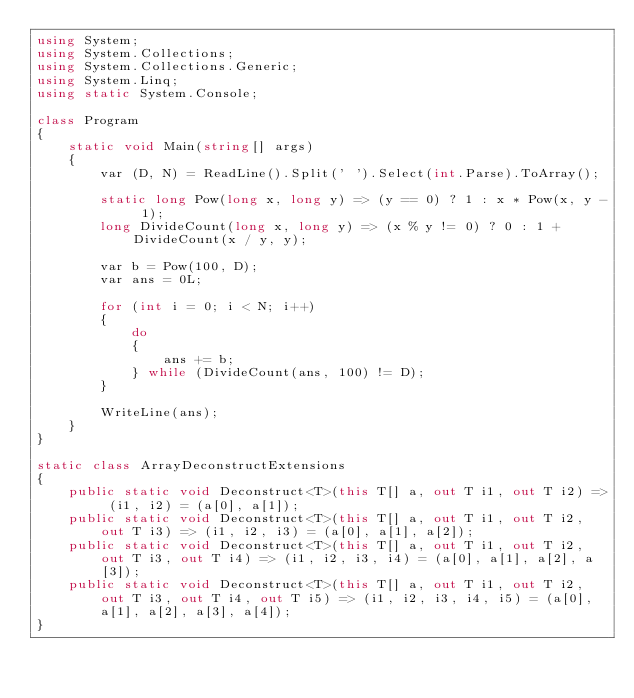Convert code to text. <code><loc_0><loc_0><loc_500><loc_500><_C#_>using System;
using System.Collections;
using System.Collections.Generic;
using System.Linq;
using static System.Console;

class Program
{
    static void Main(string[] args)
    {
        var (D, N) = ReadLine().Split(' ').Select(int.Parse).ToArray();

        static long Pow(long x, long y) => (y == 0) ? 1 : x * Pow(x, y - 1);
        long DivideCount(long x, long y) => (x % y != 0) ? 0 : 1 + DivideCount(x / y, y);

        var b = Pow(100, D);
        var ans = 0L;

        for (int i = 0; i < N; i++)
        {
            do
            {
                ans += b;
            } while (DivideCount(ans, 100) != D);
        }

        WriteLine(ans);
    }
}

static class ArrayDeconstructExtensions
{
    public static void Deconstruct<T>(this T[] a, out T i1, out T i2) => (i1, i2) = (a[0], a[1]);
    public static void Deconstruct<T>(this T[] a, out T i1, out T i2, out T i3) => (i1, i2, i3) = (a[0], a[1], a[2]);
    public static void Deconstruct<T>(this T[] a, out T i1, out T i2, out T i3, out T i4) => (i1, i2, i3, i4) = (a[0], a[1], a[2], a[3]);
    public static void Deconstruct<T>(this T[] a, out T i1, out T i2, out T i3, out T i4, out T i5) => (i1, i2, i3, i4, i5) = (a[0], a[1], a[2], a[3], a[4]);
}
</code> 